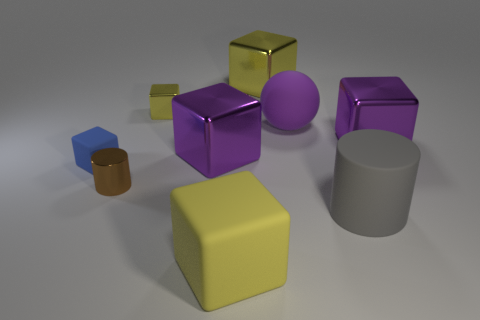Subtract all gray cylinders. How many yellow blocks are left? 3 Subtract all blue blocks. How many blocks are left? 5 Subtract all tiny yellow metallic cubes. How many cubes are left? 5 Subtract all yellow blocks. Subtract all cyan cylinders. How many blocks are left? 3 Subtract all spheres. How many objects are left? 8 Add 6 big metallic blocks. How many big metallic blocks are left? 9 Add 6 gray rubber things. How many gray rubber things exist? 7 Subtract 0 green balls. How many objects are left? 9 Subtract all big yellow metallic things. Subtract all big yellow matte blocks. How many objects are left? 7 